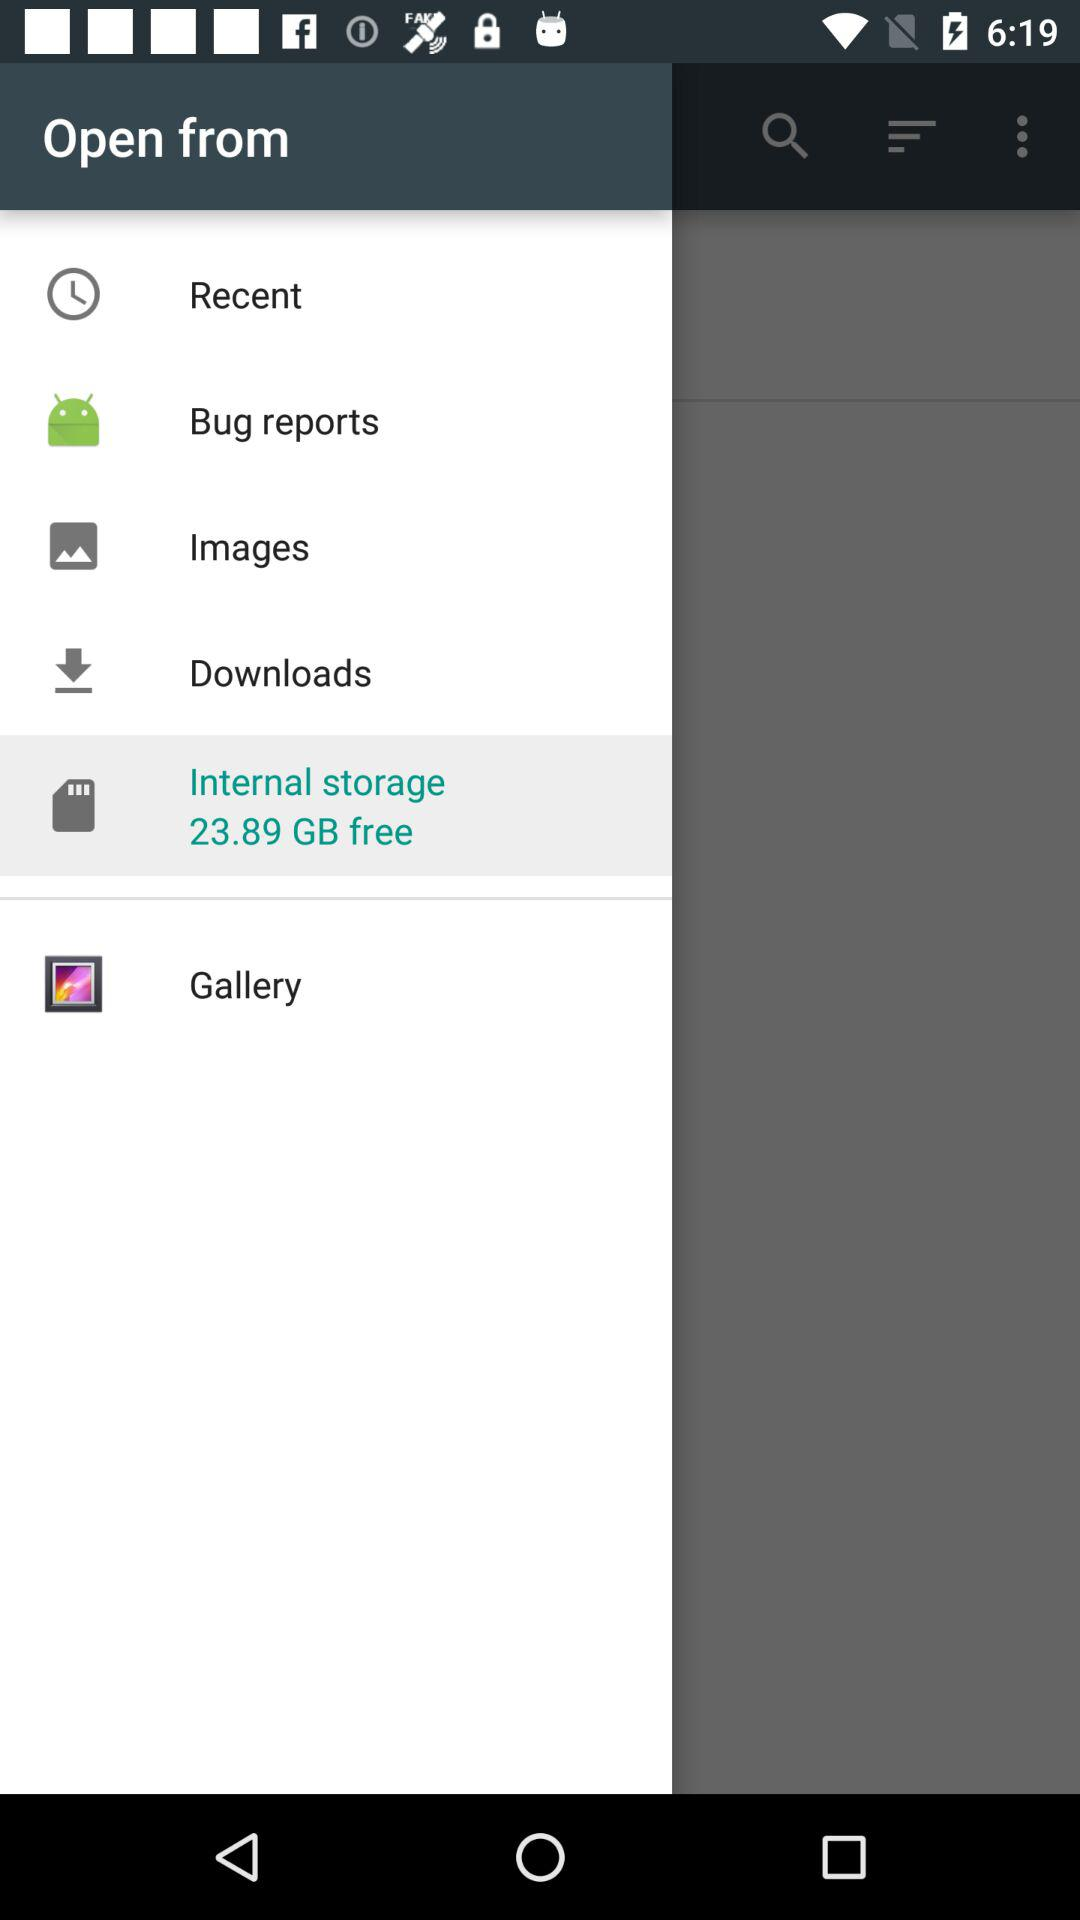How much free space is available in internal storage?
Answer the question using a single word or phrase. 23.89 GB 